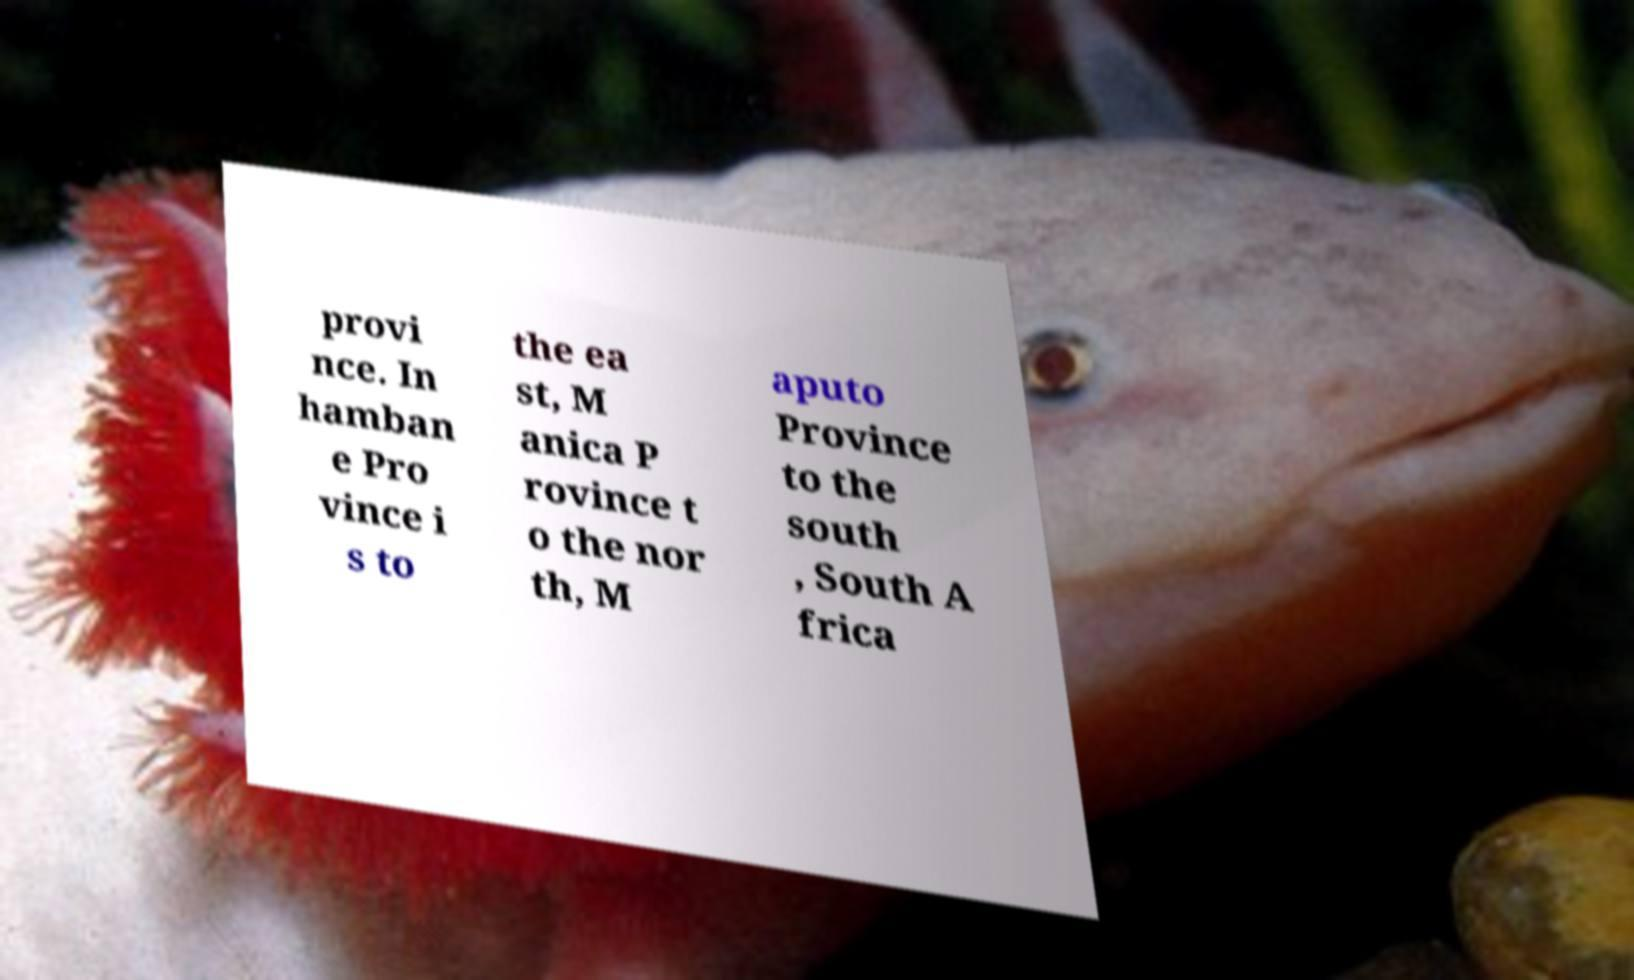There's text embedded in this image that I need extracted. Can you transcribe it verbatim? provi nce. In hamban e Pro vince i s to the ea st, M anica P rovince t o the nor th, M aputo Province to the south , South A frica 